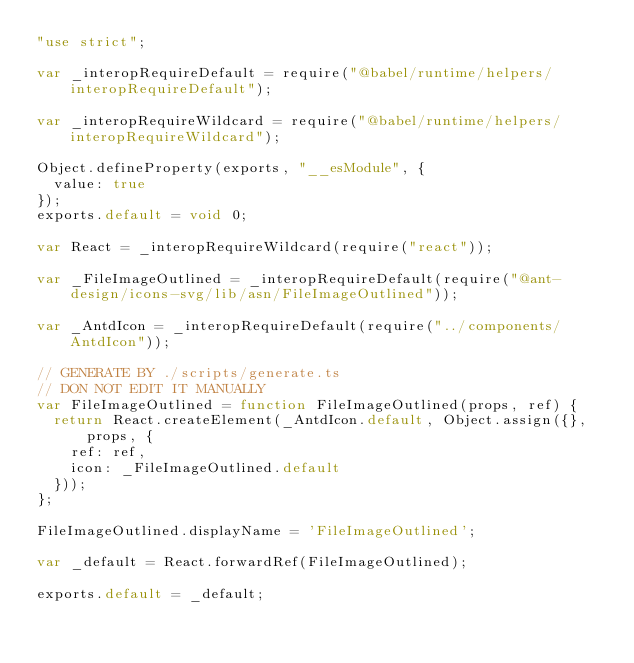<code> <loc_0><loc_0><loc_500><loc_500><_JavaScript_>"use strict";

var _interopRequireDefault = require("@babel/runtime/helpers/interopRequireDefault");

var _interopRequireWildcard = require("@babel/runtime/helpers/interopRequireWildcard");

Object.defineProperty(exports, "__esModule", {
  value: true
});
exports.default = void 0;

var React = _interopRequireWildcard(require("react"));

var _FileImageOutlined = _interopRequireDefault(require("@ant-design/icons-svg/lib/asn/FileImageOutlined"));

var _AntdIcon = _interopRequireDefault(require("../components/AntdIcon"));

// GENERATE BY ./scripts/generate.ts
// DON NOT EDIT IT MANUALLY
var FileImageOutlined = function FileImageOutlined(props, ref) {
  return React.createElement(_AntdIcon.default, Object.assign({}, props, {
    ref: ref,
    icon: _FileImageOutlined.default
  }));
};

FileImageOutlined.displayName = 'FileImageOutlined';

var _default = React.forwardRef(FileImageOutlined);

exports.default = _default;</code> 